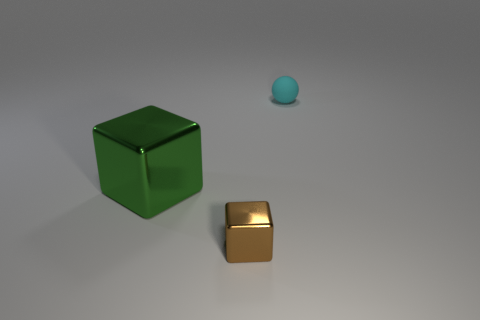Are these objects meant to represent anything specific or are they purely random? The objects in the image do not necessarily represent anything specific. They could be interpreted as an abstract composition, emphasizing form, color, and texture without representing recognizable figures or scenery.  How does the size comparison of these objects contribute to the perception of the image? The difference in size between the green and brown objects creates a sense of depth and scale. This size contrast might suggest to the viewer notions of perspective or induce a comparison in perceived value or importance between the two. 